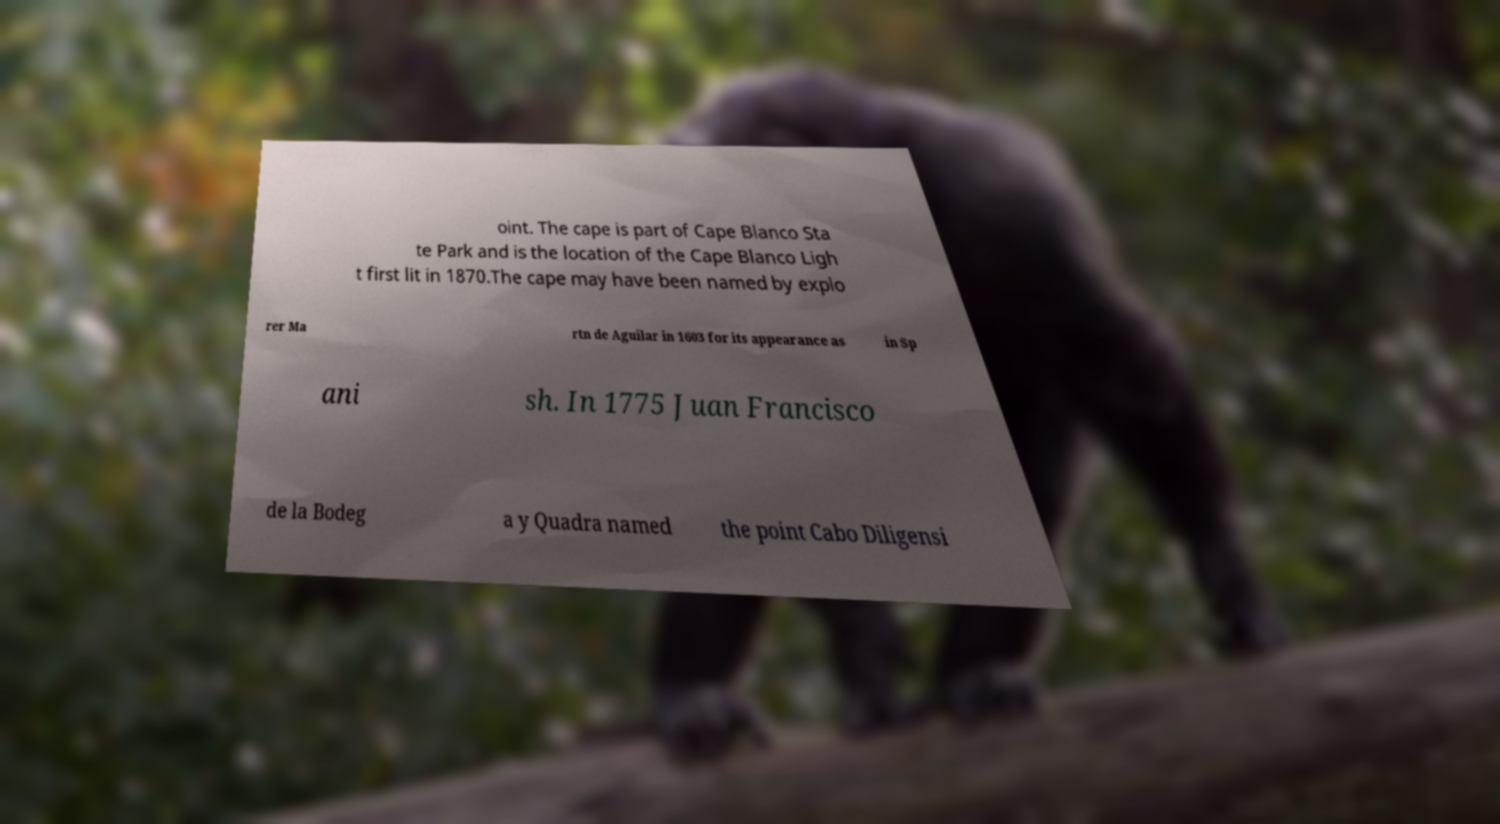Please read and relay the text visible in this image. What does it say? oint. The cape is part of Cape Blanco Sta te Park and is the location of the Cape Blanco Ligh t first lit in 1870.The cape may have been named by explo rer Ma rtn de Aguilar in 1603 for its appearance as in Sp ani sh. In 1775 Juan Francisco de la Bodeg a y Quadra named the point Cabo Diligensi 